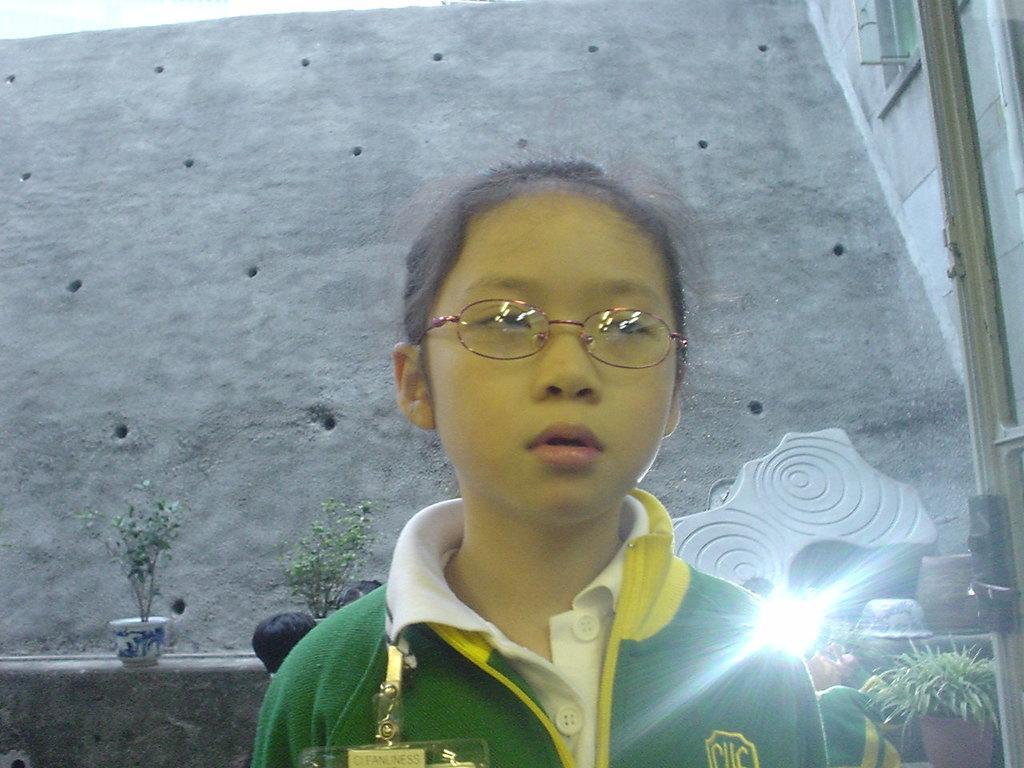Describe this image in one or two sentences. Here in this picture we can see a child standing over a place and we can see spectacles on her and behind her we can see other children standing and we can see plants present here and there. 